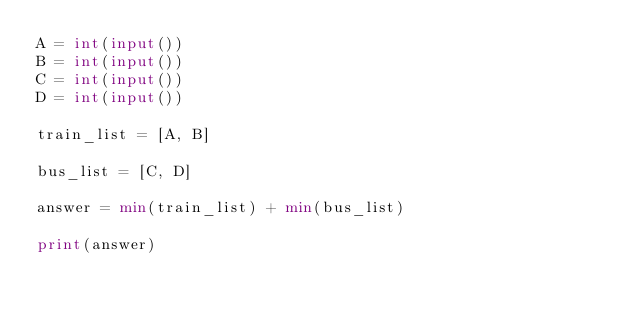Convert code to text. <code><loc_0><loc_0><loc_500><loc_500><_Python_>A = int(input())
B = int(input())
C = int(input())
D = int(input())

train_list = [A, B]

bus_list = [C, D]

answer = min(train_list) + min(bus_list)

print(answer)
</code> 